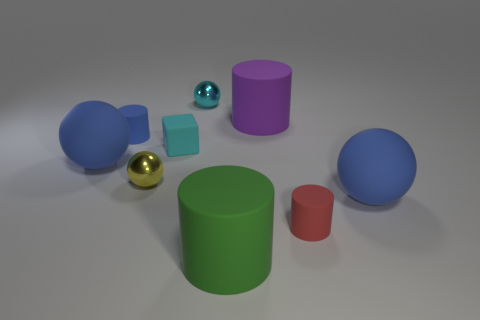What shape is the tiny shiny thing that is the same color as the tiny rubber cube?
Offer a very short reply. Sphere. There is a thing that is the same color as the matte block; what is its size?
Your answer should be compact. Small. How many other things are the same color as the small rubber cube?
Keep it short and to the point. 1. What number of cyan matte spheres are the same size as the red object?
Ensure brevity in your answer.  0. There is a metallic object that is to the right of the small yellow sphere; are there any blue things behind it?
Give a very brief answer. No. How many gray objects are either tiny cylinders or shiny objects?
Give a very brief answer. 0. The tiny cube is what color?
Make the answer very short. Cyan. There is a green cylinder that is the same material as the red cylinder; what size is it?
Ensure brevity in your answer.  Large. How many tiny blue objects have the same shape as the small red thing?
Give a very brief answer. 1. How big is the red thing in front of the ball that is to the right of the small cyan metal thing?
Provide a succinct answer. Small. 